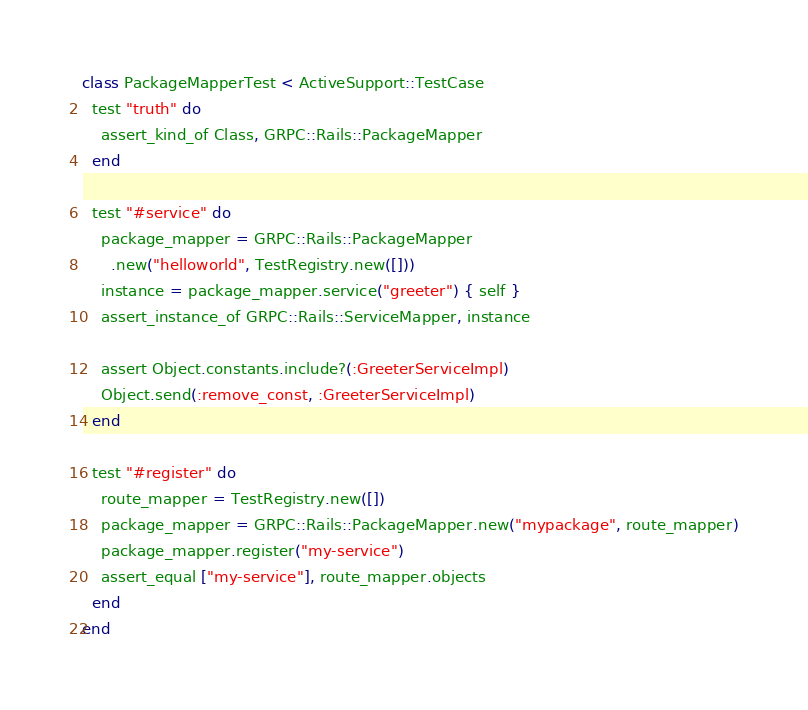<code> <loc_0><loc_0><loc_500><loc_500><_Ruby_>
class PackageMapperTest < ActiveSupport::TestCase
  test "truth" do
    assert_kind_of Class, GRPC::Rails::PackageMapper
  end

  test "#service" do
    package_mapper = GRPC::Rails::PackageMapper
      .new("helloworld", TestRegistry.new([]))
    instance = package_mapper.service("greeter") { self }
    assert_instance_of GRPC::Rails::ServiceMapper, instance

    assert Object.constants.include?(:GreeterServiceImpl)
    Object.send(:remove_const, :GreeterServiceImpl)
  end

  test "#register" do
    route_mapper = TestRegistry.new([])
    package_mapper = GRPC::Rails::PackageMapper.new("mypackage", route_mapper)
    package_mapper.register("my-service")
    assert_equal ["my-service"], route_mapper.objects
  end
end
</code> 